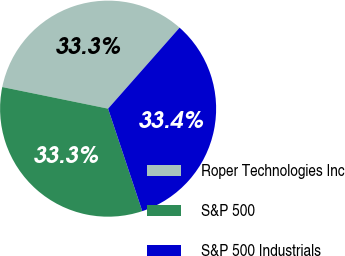<chart> <loc_0><loc_0><loc_500><loc_500><pie_chart><fcel>Roper Technologies Inc<fcel>S&P 500<fcel>S&P 500 Industrials<nl><fcel>33.3%<fcel>33.33%<fcel>33.37%<nl></chart> 